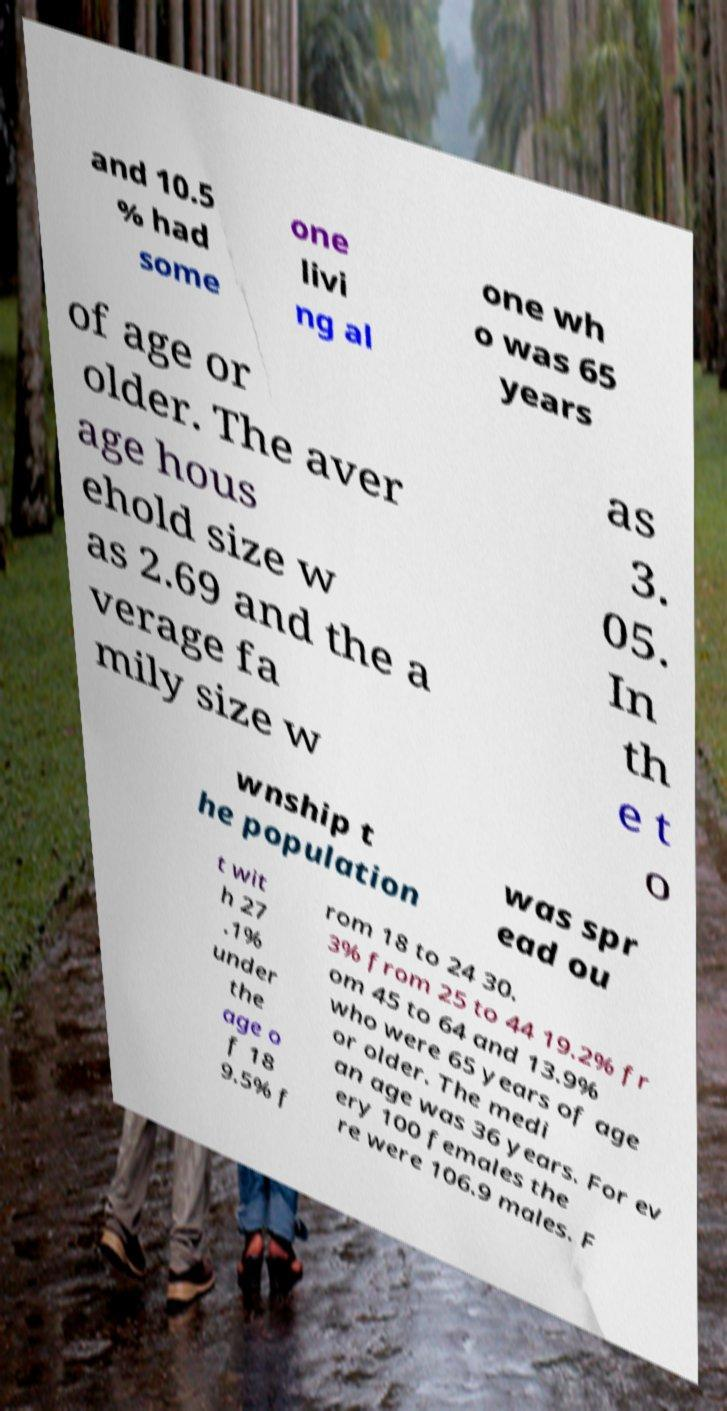Please read and relay the text visible in this image. What does it say? and 10.5 % had some one livi ng al one wh o was 65 years of age or older. The aver age hous ehold size w as 2.69 and the a verage fa mily size w as 3. 05. In th e t o wnship t he population was spr ead ou t wit h 27 .1% under the age o f 18 9.5% f rom 18 to 24 30. 3% from 25 to 44 19.2% fr om 45 to 64 and 13.9% who were 65 years of age or older. The medi an age was 36 years. For ev ery 100 females the re were 106.9 males. F 